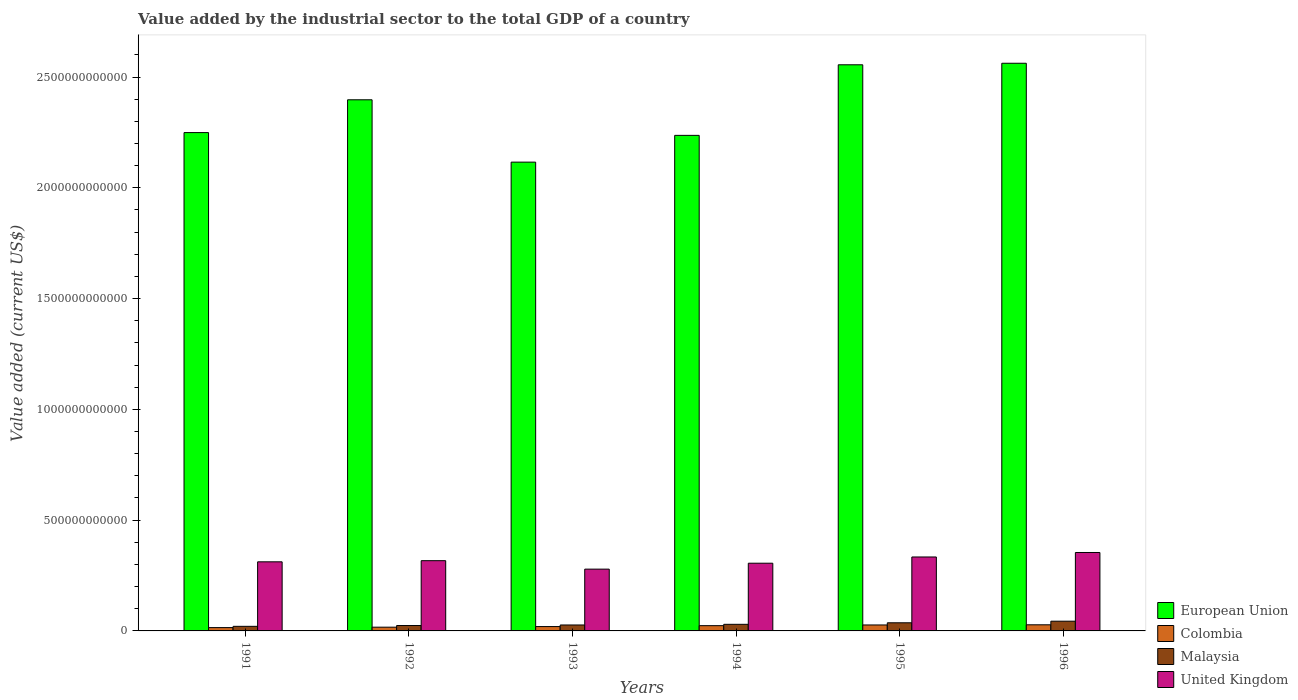How many different coloured bars are there?
Offer a terse response. 4. Are the number of bars per tick equal to the number of legend labels?
Your answer should be compact. Yes. Are the number of bars on each tick of the X-axis equal?
Your response must be concise. Yes. How many bars are there on the 5th tick from the left?
Make the answer very short. 4. How many bars are there on the 3rd tick from the right?
Offer a terse response. 4. What is the label of the 5th group of bars from the left?
Offer a terse response. 1995. In how many cases, is the number of bars for a given year not equal to the number of legend labels?
Keep it short and to the point. 0. What is the value added by the industrial sector to the total GDP in Colombia in 1993?
Make the answer very short. 1.96e+1. Across all years, what is the maximum value added by the industrial sector to the total GDP in Colombia?
Make the answer very short. 2.76e+1. Across all years, what is the minimum value added by the industrial sector to the total GDP in Colombia?
Make the answer very short. 1.50e+1. In which year was the value added by the industrial sector to the total GDP in Malaysia minimum?
Give a very brief answer. 1991. What is the total value added by the industrial sector to the total GDP in Malaysia in the graph?
Make the answer very short. 1.82e+11. What is the difference between the value added by the industrial sector to the total GDP in Malaysia in 1993 and that in 1995?
Your answer should be compact. -9.91e+09. What is the difference between the value added by the industrial sector to the total GDP in Malaysia in 1993 and the value added by the industrial sector to the total GDP in United Kingdom in 1991?
Offer a very short reply. -2.85e+11. What is the average value added by the industrial sector to the total GDP in European Union per year?
Ensure brevity in your answer.  2.35e+12. In the year 1991, what is the difference between the value added by the industrial sector to the total GDP in Colombia and value added by the industrial sector to the total GDP in United Kingdom?
Provide a succinct answer. -2.97e+11. In how many years, is the value added by the industrial sector to the total GDP in European Union greater than 1600000000000 US$?
Make the answer very short. 6. What is the ratio of the value added by the industrial sector to the total GDP in United Kingdom in 1993 to that in 1996?
Your answer should be very brief. 0.79. Is the value added by the industrial sector to the total GDP in European Union in 1994 less than that in 1995?
Your response must be concise. Yes. What is the difference between the highest and the second highest value added by the industrial sector to the total GDP in Malaysia?
Your answer should be very brief. 7.17e+09. What is the difference between the highest and the lowest value added by the industrial sector to the total GDP in European Union?
Make the answer very short. 4.46e+11. What does the 4th bar from the right in 1992 represents?
Provide a succinct answer. European Union. What is the difference between two consecutive major ticks on the Y-axis?
Your answer should be very brief. 5.00e+11. Does the graph contain grids?
Ensure brevity in your answer.  No. Where does the legend appear in the graph?
Provide a short and direct response. Bottom right. What is the title of the graph?
Provide a succinct answer. Value added by the industrial sector to the total GDP of a country. Does "Dominica" appear as one of the legend labels in the graph?
Keep it short and to the point. No. What is the label or title of the Y-axis?
Ensure brevity in your answer.  Value added (current US$). What is the Value added (current US$) of European Union in 1991?
Make the answer very short. 2.25e+12. What is the Value added (current US$) in Colombia in 1991?
Make the answer very short. 1.50e+1. What is the Value added (current US$) in Malaysia in 1991?
Your answer should be very brief. 2.07e+1. What is the Value added (current US$) of United Kingdom in 1991?
Your response must be concise. 3.12e+11. What is the Value added (current US$) of European Union in 1992?
Keep it short and to the point. 2.40e+12. What is the Value added (current US$) of Colombia in 1992?
Keep it short and to the point. 1.69e+1. What is the Value added (current US$) of Malaysia in 1992?
Provide a short and direct response. 2.43e+1. What is the Value added (current US$) in United Kingdom in 1992?
Your answer should be compact. 3.17e+11. What is the Value added (current US$) of European Union in 1993?
Make the answer very short. 2.12e+12. What is the Value added (current US$) in Colombia in 1993?
Keep it short and to the point. 1.96e+1. What is the Value added (current US$) in Malaysia in 1993?
Provide a succinct answer. 2.68e+1. What is the Value added (current US$) of United Kingdom in 1993?
Provide a succinct answer. 2.79e+11. What is the Value added (current US$) in European Union in 1994?
Provide a short and direct response. 2.24e+12. What is the Value added (current US$) of Colombia in 1994?
Give a very brief answer. 2.37e+1. What is the Value added (current US$) in Malaysia in 1994?
Make the answer very short. 2.98e+1. What is the Value added (current US$) of United Kingdom in 1994?
Provide a succinct answer. 3.06e+11. What is the Value added (current US$) in European Union in 1995?
Provide a succinct answer. 2.56e+12. What is the Value added (current US$) of Colombia in 1995?
Your response must be concise. 2.69e+1. What is the Value added (current US$) in Malaysia in 1995?
Keep it short and to the point. 3.67e+1. What is the Value added (current US$) in United Kingdom in 1995?
Make the answer very short. 3.34e+11. What is the Value added (current US$) of European Union in 1996?
Offer a very short reply. 2.56e+12. What is the Value added (current US$) in Colombia in 1996?
Make the answer very short. 2.76e+1. What is the Value added (current US$) of Malaysia in 1996?
Give a very brief answer. 4.39e+1. What is the Value added (current US$) of United Kingdom in 1996?
Make the answer very short. 3.54e+11. Across all years, what is the maximum Value added (current US$) in European Union?
Offer a terse response. 2.56e+12. Across all years, what is the maximum Value added (current US$) of Colombia?
Give a very brief answer. 2.76e+1. Across all years, what is the maximum Value added (current US$) of Malaysia?
Your answer should be very brief. 4.39e+1. Across all years, what is the maximum Value added (current US$) in United Kingdom?
Ensure brevity in your answer.  3.54e+11. Across all years, what is the minimum Value added (current US$) of European Union?
Offer a very short reply. 2.12e+12. Across all years, what is the minimum Value added (current US$) in Colombia?
Keep it short and to the point. 1.50e+1. Across all years, what is the minimum Value added (current US$) in Malaysia?
Provide a succinct answer. 2.07e+1. Across all years, what is the minimum Value added (current US$) in United Kingdom?
Ensure brevity in your answer.  2.79e+11. What is the total Value added (current US$) of European Union in the graph?
Your response must be concise. 1.41e+13. What is the total Value added (current US$) of Colombia in the graph?
Provide a succinct answer. 1.30e+11. What is the total Value added (current US$) of Malaysia in the graph?
Offer a terse response. 1.82e+11. What is the total Value added (current US$) in United Kingdom in the graph?
Your answer should be very brief. 1.90e+12. What is the difference between the Value added (current US$) in European Union in 1991 and that in 1992?
Your response must be concise. -1.48e+11. What is the difference between the Value added (current US$) in Colombia in 1991 and that in 1992?
Ensure brevity in your answer.  -1.91e+09. What is the difference between the Value added (current US$) of Malaysia in 1991 and that in 1992?
Offer a very short reply. -3.65e+09. What is the difference between the Value added (current US$) in United Kingdom in 1991 and that in 1992?
Ensure brevity in your answer.  -5.13e+09. What is the difference between the Value added (current US$) of European Union in 1991 and that in 1993?
Ensure brevity in your answer.  1.33e+11. What is the difference between the Value added (current US$) of Colombia in 1991 and that in 1993?
Provide a succinct answer. -4.66e+09. What is the difference between the Value added (current US$) of Malaysia in 1991 and that in 1993?
Your response must be concise. -6.12e+09. What is the difference between the Value added (current US$) of United Kingdom in 1991 and that in 1993?
Give a very brief answer. 3.30e+1. What is the difference between the Value added (current US$) of European Union in 1991 and that in 1994?
Give a very brief answer. 1.25e+1. What is the difference between the Value added (current US$) of Colombia in 1991 and that in 1994?
Your response must be concise. -8.73e+09. What is the difference between the Value added (current US$) in Malaysia in 1991 and that in 1994?
Provide a short and direct response. -9.13e+09. What is the difference between the Value added (current US$) in United Kingdom in 1991 and that in 1994?
Your response must be concise. 6.26e+09. What is the difference between the Value added (current US$) of European Union in 1991 and that in 1995?
Keep it short and to the point. -3.06e+11. What is the difference between the Value added (current US$) in Colombia in 1991 and that in 1995?
Provide a short and direct response. -1.19e+1. What is the difference between the Value added (current US$) in Malaysia in 1991 and that in 1995?
Make the answer very short. -1.60e+1. What is the difference between the Value added (current US$) of United Kingdom in 1991 and that in 1995?
Provide a short and direct response. -2.19e+1. What is the difference between the Value added (current US$) of European Union in 1991 and that in 1996?
Your answer should be very brief. -3.13e+11. What is the difference between the Value added (current US$) in Colombia in 1991 and that in 1996?
Provide a succinct answer. -1.26e+1. What is the difference between the Value added (current US$) in Malaysia in 1991 and that in 1996?
Give a very brief answer. -2.32e+1. What is the difference between the Value added (current US$) of United Kingdom in 1991 and that in 1996?
Your answer should be very brief. -4.21e+1. What is the difference between the Value added (current US$) in European Union in 1992 and that in 1993?
Your answer should be very brief. 2.81e+11. What is the difference between the Value added (current US$) of Colombia in 1992 and that in 1993?
Provide a short and direct response. -2.75e+09. What is the difference between the Value added (current US$) in Malaysia in 1992 and that in 1993?
Your answer should be very brief. -2.47e+09. What is the difference between the Value added (current US$) of United Kingdom in 1992 and that in 1993?
Your answer should be compact. 3.81e+1. What is the difference between the Value added (current US$) of European Union in 1992 and that in 1994?
Ensure brevity in your answer.  1.61e+11. What is the difference between the Value added (current US$) in Colombia in 1992 and that in 1994?
Make the answer very short. -6.82e+09. What is the difference between the Value added (current US$) of Malaysia in 1992 and that in 1994?
Provide a short and direct response. -5.48e+09. What is the difference between the Value added (current US$) of United Kingdom in 1992 and that in 1994?
Your response must be concise. 1.14e+1. What is the difference between the Value added (current US$) in European Union in 1992 and that in 1995?
Make the answer very short. -1.58e+11. What is the difference between the Value added (current US$) of Colombia in 1992 and that in 1995?
Your response must be concise. -1.00e+1. What is the difference between the Value added (current US$) in Malaysia in 1992 and that in 1995?
Your response must be concise. -1.24e+1. What is the difference between the Value added (current US$) in United Kingdom in 1992 and that in 1995?
Offer a terse response. -1.68e+1. What is the difference between the Value added (current US$) of European Union in 1992 and that in 1996?
Your answer should be compact. -1.65e+11. What is the difference between the Value added (current US$) of Colombia in 1992 and that in 1996?
Keep it short and to the point. -1.07e+1. What is the difference between the Value added (current US$) in Malaysia in 1992 and that in 1996?
Provide a short and direct response. -1.96e+1. What is the difference between the Value added (current US$) in United Kingdom in 1992 and that in 1996?
Your response must be concise. -3.70e+1. What is the difference between the Value added (current US$) in European Union in 1993 and that in 1994?
Make the answer very short. -1.21e+11. What is the difference between the Value added (current US$) in Colombia in 1993 and that in 1994?
Provide a succinct answer. -4.07e+09. What is the difference between the Value added (current US$) in Malaysia in 1993 and that in 1994?
Offer a very short reply. -3.01e+09. What is the difference between the Value added (current US$) of United Kingdom in 1993 and that in 1994?
Offer a terse response. -2.67e+1. What is the difference between the Value added (current US$) in European Union in 1993 and that in 1995?
Give a very brief answer. -4.39e+11. What is the difference between the Value added (current US$) of Colombia in 1993 and that in 1995?
Your answer should be very brief. -7.26e+09. What is the difference between the Value added (current US$) in Malaysia in 1993 and that in 1995?
Give a very brief answer. -9.91e+09. What is the difference between the Value added (current US$) of United Kingdom in 1993 and that in 1995?
Offer a very short reply. -5.49e+1. What is the difference between the Value added (current US$) in European Union in 1993 and that in 1996?
Your response must be concise. -4.46e+11. What is the difference between the Value added (current US$) in Colombia in 1993 and that in 1996?
Provide a succinct answer. -7.99e+09. What is the difference between the Value added (current US$) in Malaysia in 1993 and that in 1996?
Your response must be concise. -1.71e+1. What is the difference between the Value added (current US$) in United Kingdom in 1993 and that in 1996?
Keep it short and to the point. -7.51e+1. What is the difference between the Value added (current US$) of European Union in 1994 and that in 1995?
Provide a short and direct response. -3.19e+11. What is the difference between the Value added (current US$) in Colombia in 1994 and that in 1995?
Ensure brevity in your answer.  -3.20e+09. What is the difference between the Value added (current US$) in Malaysia in 1994 and that in 1995?
Provide a short and direct response. -6.90e+09. What is the difference between the Value added (current US$) of United Kingdom in 1994 and that in 1995?
Provide a short and direct response. -2.81e+1. What is the difference between the Value added (current US$) of European Union in 1994 and that in 1996?
Give a very brief answer. -3.25e+11. What is the difference between the Value added (current US$) of Colombia in 1994 and that in 1996?
Provide a succinct answer. -3.92e+09. What is the difference between the Value added (current US$) in Malaysia in 1994 and that in 1996?
Your response must be concise. -1.41e+1. What is the difference between the Value added (current US$) of United Kingdom in 1994 and that in 1996?
Provide a succinct answer. -4.83e+1. What is the difference between the Value added (current US$) of European Union in 1995 and that in 1996?
Provide a succinct answer. -6.93e+09. What is the difference between the Value added (current US$) of Colombia in 1995 and that in 1996?
Provide a short and direct response. -7.25e+08. What is the difference between the Value added (current US$) of Malaysia in 1995 and that in 1996?
Provide a succinct answer. -7.17e+09. What is the difference between the Value added (current US$) in United Kingdom in 1995 and that in 1996?
Provide a short and direct response. -2.02e+1. What is the difference between the Value added (current US$) of European Union in 1991 and the Value added (current US$) of Colombia in 1992?
Offer a terse response. 2.23e+12. What is the difference between the Value added (current US$) of European Union in 1991 and the Value added (current US$) of Malaysia in 1992?
Give a very brief answer. 2.22e+12. What is the difference between the Value added (current US$) in European Union in 1991 and the Value added (current US$) in United Kingdom in 1992?
Make the answer very short. 1.93e+12. What is the difference between the Value added (current US$) of Colombia in 1991 and the Value added (current US$) of Malaysia in 1992?
Keep it short and to the point. -9.38e+09. What is the difference between the Value added (current US$) in Colombia in 1991 and the Value added (current US$) in United Kingdom in 1992?
Give a very brief answer. -3.02e+11. What is the difference between the Value added (current US$) of Malaysia in 1991 and the Value added (current US$) of United Kingdom in 1992?
Provide a short and direct response. -2.96e+11. What is the difference between the Value added (current US$) of European Union in 1991 and the Value added (current US$) of Colombia in 1993?
Offer a terse response. 2.23e+12. What is the difference between the Value added (current US$) in European Union in 1991 and the Value added (current US$) in Malaysia in 1993?
Ensure brevity in your answer.  2.22e+12. What is the difference between the Value added (current US$) in European Union in 1991 and the Value added (current US$) in United Kingdom in 1993?
Offer a terse response. 1.97e+12. What is the difference between the Value added (current US$) of Colombia in 1991 and the Value added (current US$) of Malaysia in 1993?
Your response must be concise. -1.18e+1. What is the difference between the Value added (current US$) of Colombia in 1991 and the Value added (current US$) of United Kingdom in 1993?
Your answer should be very brief. -2.64e+11. What is the difference between the Value added (current US$) in Malaysia in 1991 and the Value added (current US$) in United Kingdom in 1993?
Offer a terse response. -2.58e+11. What is the difference between the Value added (current US$) in European Union in 1991 and the Value added (current US$) in Colombia in 1994?
Ensure brevity in your answer.  2.23e+12. What is the difference between the Value added (current US$) in European Union in 1991 and the Value added (current US$) in Malaysia in 1994?
Your response must be concise. 2.22e+12. What is the difference between the Value added (current US$) in European Union in 1991 and the Value added (current US$) in United Kingdom in 1994?
Give a very brief answer. 1.94e+12. What is the difference between the Value added (current US$) of Colombia in 1991 and the Value added (current US$) of Malaysia in 1994?
Provide a short and direct response. -1.49e+1. What is the difference between the Value added (current US$) in Colombia in 1991 and the Value added (current US$) in United Kingdom in 1994?
Provide a short and direct response. -2.91e+11. What is the difference between the Value added (current US$) of Malaysia in 1991 and the Value added (current US$) of United Kingdom in 1994?
Make the answer very short. -2.85e+11. What is the difference between the Value added (current US$) in European Union in 1991 and the Value added (current US$) in Colombia in 1995?
Offer a terse response. 2.22e+12. What is the difference between the Value added (current US$) in European Union in 1991 and the Value added (current US$) in Malaysia in 1995?
Provide a succinct answer. 2.21e+12. What is the difference between the Value added (current US$) in European Union in 1991 and the Value added (current US$) in United Kingdom in 1995?
Make the answer very short. 1.92e+12. What is the difference between the Value added (current US$) in Colombia in 1991 and the Value added (current US$) in Malaysia in 1995?
Give a very brief answer. -2.18e+1. What is the difference between the Value added (current US$) in Colombia in 1991 and the Value added (current US$) in United Kingdom in 1995?
Give a very brief answer. -3.19e+11. What is the difference between the Value added (current US$) of Malaysia in 1991 and the Value added (current US$) of United Kingdom in 1995?
Provide a succinct answer. -3.13e+11. What is the difference between the Value added (current US$) of European Union in 1991 and the Value added (current US$) of Colombia in 1996?
Your answer should be compact. 2.22e+12. What is the difference between the Value added (current US$) in European Union in 1991 and the Value added (current US$) in Malaysia in 1996?
Provide a short and direct response. 2.21e+12. What is the difference between the Value added (current US$) in European Union in 1991 and the Value added (current US$) in United Kingdom in 1996?
Ensure brevity in your answer.  1.90e+12. What is the difference between the Value added (current US$) in Colombia in 1991 and the Value added (current US$) in Malaysia in 1996?
Keep it short and to the point. -2.89e+1. What is the difference between the Value added (current US$) of Colombia in 1991 and the Value added (current US$) of United Kingdom in 1996?
Make the answer very short. -3.39e+11. What is the difference between the Value added (current US$) in Malaysia in 1991 and the Value added (current US$) in United Kingdom in 1996?
Offer a very short reply. -3.33e+11. What is the difference between the Value added (current US$) in European Union in 1992 and the Value added (current US$) in Colombia in 1993?
Make the answer very short. 2.38e+12. What is the difference between the Value added (current US$) of European Union in 1992 and the Value added (current US$) of Malaysia in 1993?
Give a very brief answer. 2.37e+12. What is the difference between the Value added (current US$) of European Union in 1992 and the Value added (current US$) of United Kingdom in 1993?
Offer a terse response. 2.12e+12. What is the difference between the Value added (current US$) in Colombia in 1992 and the Value added (current US$) in Malaysia in 1993?
Provide a short and direct response. -9.94e+09. What is the difference between the Value added (current US$) of Colombia in 1992 and the Value added (current US$) of United Kingdom in 1993?
Your answer should be compact. -2.62e+11. What is the difference between the Value added (current US$) of Malaysia in 1992 and the Value added (current US$) of United Kingdom in 1993?
Provide a short and direct response. -2.55e+11. What is the difference between the Value added (current US$) of European Union in 1992 and the Value added (current US$) of Colombia in 1994?
Make the answer very short. 2.37e+12. What is the difference between the Value added (current US$) of European Union in 1992 and the Value added (current US$) of Malaysia in 1994?
Offer a very short reply. 2.37e+12. What is the difference between the Value added (current US$) in European Union in 1992 and the Value added (current US$) in United Kingdom in 1994?
Provide a short and direct response. 2.09e+12. What is the difference between the Value added (current US$) of Colombia in 1992 and the Value added (current US$) of Malaysia in 1994?
Give a very brief answer. -1.29e+1. What is the difference between the Value added (current US$) of Colombia in 1992 and the Value added (current US$) of United Kingdom in 1994?
Keep it short and to the point. -2.89e+11. What is the difference between the Value added (current US$) of Malaysia in 1992 and the Value added (current US$) of United Kingdom in 1994?
Ensure brevity in your answer.  -2.81e+11. What is the difference between the Value added (current US$) of European Union in 1992 and the Value added (current US$) of Colombia in 1995?
Your response must be concise. 2.37e+12. What is the difference between the Value added (current US$) of European Union in 1992 and the Value added (current US$) of Malaysia in 1995?
Ensure brevity in your answer.  2.36e+12. What is the difference between the Value added (current US$) of European Union in 1992 and the Value added (current US$) of United Kingdom in 1995?
Your answer should be compact. 2.06e+12. What is the difference between the Value added (current US$) of Colombia in 1992 and the Value added (current US$) of Malaysia in 1995?
Your response must be concise. -1.98e+1. What is the difference between the Value added (current US$) of Colombia in 1992 and the Value added (current US$) of United Kingdom in 1995?
Your response must be concise. -3.17e+11. What is the difference between the Value added (current US$) of Malaysia in 1992 and the Value added (current US$) of United Kingdom in 1995?
Your answer should be very brief. -3.09e+11. What is the difference between the Value added (current US$) of European Union in 1992 and the Value added (current US$) of Colombia in 1996?
Provide a short and direct response. 2.37e+12. What is the difference between the Value added (current US$) of European Union in 1992 and the Value added (current US$) of Malaysia in 1996?
Your answer should be compact. 2.35e+12. What is the difference between the Value added (current US$) of European Union in 1992 and the Value added (current US$) of United Kingdom in 1996?
Ensure brevity in your answer.  2.04e+12. What is the difference between the Value added (current US$) of Colombia in 1992 and the Value added (current US$) of Malaysia in 1996?
Give a very brief answer. -2.70e+1. What is the difference between the Value added (current US$) of Colombia in 1992 and the Value added (current US$) of United Kingdom in 1996?
Your response must be concise. -3.37e+11. What is the difference between the Value added (current US$) in Malaysia in 1992 and the Value added (current US$) in United Kingdom in 1996?
Provide a succinct answer. -3.30e+11. What is the difference between the Value added (current US$) in European Union in 1993 and the Value added (current US$) in Colombia in 1994?
Provide a succinct answer. 2.09e+12. What is the difference between the Value added (current US$) in European Union in 1993 and the Value added (current US$) in Malaysia in 1994?
Your answer should be compact. 2.09e+12. What is the difference between the Value added (current US$) in European Union in 1993 and the Value added (current US$) in United Kingdom in 1994?
Your answer should be very brief. 1.81e+12. What is the difference between the Value added (current US$) in Colombia in 1993 and the Value added (current US$) in Malaysia in 1994?
Your response must be concise. -1.02e+1. What is the difference between the Value added (current US$) of Colombia in 1993 and the Value added (current US$) of United Kingdom in 1994?
Provide a short and direct response. -2.86e+11. What is the difference between the Value added (current US$) of Malaysia in 1993 and the Value added (current US$) of United Kingdom in 1994?
Give a very brief answer. -2.79e+11. What is the difference between the Value added (current US$) of European Union in 1993 and the Value added (current US$) of Colombia in 1995?
Offer a terse response. 2.09e+12. What is the difference between the Value added (current US$) of European Union in 1993 and the Value added (current US$) of Malaysia in 1995?
Your response must be concise. 2.08e+12. What is the difference between the Value added (current US$) of European Union in 1993 and the Value added (current US$) of United Kingdom in 1995?
Keep it short and to the point. 1.78e+12. What is the difference between the Value added (current US$) of Colombia in 1993 and the Value added (current US$) of Malaysia in 1995?
Your answer should be compact. -1.71e+1. What is the difference between the Value added (current US$) of Colombia in 1993 and the Value added (current US$) of United Kingdom in 1995?
Give a very brief answer. -3.14e+11. What is the difference between the Value added (current US$) of Malaysia in 1993 and the Value added (current US$) of United Kingdom in 1995?
Make the answer very short. -3.07e+11. What is the difference between the Value added (current US$) in European Union in 1993 and the Value added (current US$) in Colombia in 1996?
Make the answer very short. 2.09e+12. What is the difference between the Value added (current US$) of European Union in 1993 and the Value added (current US$) of Malaysia in 1996?
Make the answer very short. 2.07e+12. What is the difference between the Value added (current US$) in European Union in 1993 and the Value added (current US$) in United Kingdom in 1996?
Offer a terse response. 1.76e+12. What is the difference between the Value added (current US$) of Colombia in 1993 and the Value added (current US$) of Malaysia in 1996?
Provide a succinct answer. -2.43e+1. What is the difference between the Value added (current US$) in Colombia in 1993 and the Value added (current US$) in United Kingdom in 1996?
Provide a succinct answer. -3.34e+11. What is the difference between the Value added (current US$) of Malaysia in 1993 and the Value added (current US$) of United Kingdom in 1996?
Your answer should be compact. -3.27e+11. What is the difference between the Value added (current US$) in European Union in 1994 and the Value added (current US$) in Colombia in 1995?
Your answer should be very brief. 2.21e+12. What is the difference between the Value added (current US$) in European Union in 1994 and the Value added (current US$) in Malaysia in 1995?
Offer a terse response. 2.20e+12. What is the difference between the Value added (current US$) of European Union in 1994 and the Value added (current US$) of United Kingdom in 1995?
Make the answer very short. 1.90e+12. What is the difference between the Value added (current US$) in Colombia in 1994 and the Value added (current US$) in Malaysia in 1995?
Offer a very short reply. -1.30e+1. What is the difference between the Value added (current US$) of Colombia in 1994 and the Value added (current US$) of United Kingdom in 1995?
Offer a terse response. -3.10e+11. What is the difference between the Value added (current US$) of Malaysia in 1994 and the Value added (current US$) of United Kingdom in 1995?
Your response must be concise. -3.04e+11. What is the difference between the Value added (current US$) in European Union in 1994 and the Value added (current US$) in Colombia in 1996?
Your answer should be compact. 2.21e+12. What is the difference between the Value added (current US$) of European Union in 1994 and the Value added (current US$) of Malaysia in 1996?
Ensure brevity in your answer.  2.19e+12. What is the difference between the Value added (current US$) in European Union in 1994 and the Value added (current US$) in United Kingdom in 1996?
Give a very brief answer. 1.88e+12. What is the difference between the Value added (current US$) of Colombia in 1994 and the Value added (current US$) of Malaysia in 1996?
Make the answer very short. -2.02e+1. What is the difference between the Value added (current US$) of Colombia in 1994 and the Value added (current US$) of United Kingdom in 1996?
Give a very brief answer. -3.30e+11. What is the difference between the Value added (current US$) in Malaysia in 1994 and the Value added (current US$) in United Kingdom in 1996?
Provide a succinct answer. -3.24e+11. What is the difference between the Value added (current US$) of European Union in 1995 and the Value added (current US$) of Colombia in 1996?
Your answer should be compact. 2.53e+12. What is the difference between the Value added (current US$) in European Union in 1995 and the Value added (current US$) in Malaysia in 1996?
Give a very brief answer. 2.51e+12. What is the difference between the Value added (current US$) in European Union in 1995 and the Value added (current US$) in United Kingdom in 1996?
Your response must be concise. 2.20e+12. What is the difference between the Value added (current US$) of Colombia in 1995 and the Value added (current US$) of Malaysia in 1996?
Ensure brevity in your answer.  -1.70e+1. What is the difference between the Value added (current US$) in Colombia in 1995 and the Value added (current US$) in United Kingdom in 1996?
Provide a short and direct response. -3.27e+11. What is the difference between the Value added (current US$) of Malaysia in 1995 and the Value added (current US$) of United Kingdom in 1996?
Keep it short and to the point. -3.17e+11. What is the average Value added (current US$) in European Union per year?
Make the answer very short. 2.35e+12. What is the average Value added (current US$) in Colombia per year?
Your answer should be very brief. 2.16e+1. What is the average Value added (current US$) in Malaysia per year?
Make the answer very short. 3.04e+1. What is the average Value added (current US$) in United Kingdom per year?
Ensure brevity in your answer.  3.17e+11. In the year 1991, what is the difference between the Value added (current US$) in European Union and Value added (current US$) in Colombia?
Your response must be concise. 2.23e+12. In the year 1991, what is the difference between the Value added (current US$) in European Union and Value added (current US$) in Malaysia?
Your answer should be very brief. 2.23e+12. In the year 1991, what is the difference between the Value added (current US$) of European Union and Value added (current US$) of United Kingdom?
Provide a succinct answer. 1.94e+12. In the year 1991, what is the difference between the Value added (current US$) in Colombia and Value added (current US$) in Malaysia?
Ensure brevity in your answer.  -5.72e+09. In the year 1991, what is the difference between the Value added (current US$) of Colombia and Value added (current US$) of United Kingdom?
Provide a succinct answer. -2.97e+11. In the year 1991, what is the difference between the Value added (current US$) of Malaysia and Value added (current US$) of United Kingdom?
Your answer should be compact. -2.91e+11. In the year 1992, what is the difference between the Value added (current US$) in European Union and Value added (current US$) in Colombia?
Offer a very short reply. 2.38e+12. In the year 1992, what is the difference between the Value added (current US$) of European Union and Value added (current US$) of Malaysia?
Keep it short and to the point. 2.37e+12. In the year 1992, what is the difference between the Value added (current US$) in European Union and Value added (current US$) in United Kingdom?
Keep it short and to the point. 2.08e+12. In the year 1992, what is the difference between the Value added (current US$) in Colombia and Value added (current US$) in Malaysia?
Offer a terse response. -7.47e+09. In the year 1992, what is the difference between the Value added (current US$) in Colombia and Value added (current US$) in United Kingdom?
Offer a very short reply. -3.00e+11. In the year 1992, what is the difference between the Value added (current US$) of Malaysia and Value added (current US$) of United Kingdom?
Your answer should be very brief. -2.93e+11. In the year 1993, what is the difference between the Value added (current US$) of European Union and Value added (current US$) of Colombia?
Your answer should be very brief. 2.10e+12. In the year 1993, what is the difference between the Value added (current US$) in European Union and Value added (current US$) in Malaysia?
Give a very brief answer. 2.09e+12. In the year 1993, what is the difference between the Value added (current US$) in European Union and Value added (current US$) in United Kingdom?
Your answer should be compact. 1.84e+12. In the year 1993, what is the difference between the Value added (current US$) of Colombia and Value added (current US$) of Malaysia?
Your response must be concise. -7.19e+09. In the year 1993, what is the difference between the Value added (current US$) of Colombia and Value added (current US$) of United Kingdom?
Offer a very short reply. -2.59e+11. In the year 1993, what is the difference between the Value added (current US$) of Malaysia and Value added (current US$) of United Kingdom?
Your answer should be compact. -2.52e+11. In the year 1994, what is the difference between the Value added (current US$) in European Union and Value added (current US$) in Colombia?
Give a very brief answer. 2.21e+12. In the year 1994, what is the difference between the Value added (current US$) in European Union and Value added (current US$) in Malaysia?
Make the answer very short. 2.21e+12. In the year 1994, what is the difference between the Value added (current US$) in European Union and Value added (current US$) in United Kingdom?
Offer a very short reply. 1.93e+12. In the year 1994, what is the difference between the Value added (current US$) of Colombia and Value added (current US$) of Malaysia?
Offer a terse response. -6.13e+09. In the year 1994, what is the difference between the Value added (current US$) of Colombia and Value added (current US$) of United Kingdom?
Offer a terse response. -2.82e+11. In the year 1994, what is the difference between the Value added (current US$) of Malaysia and Value added (current US$) of United Kingdom?
Your answer should be compact. -2.76e+11. In the year 1995, what is the difference between the Value added (current US$) of European Union and Value added (current US$) of Colombia?
Your answer should be compact. 2.53e+12. In the year 1995, what is the difference between the Value added (current US$) of European Union and Value added (current US$) of Malaysia?
Offer a very short reply. 2.52e+12. In the year 1995, what is the difference between the Value added (current US$) in European Union and Value added (current US$) in United Kingdom?
Provide a succinct answer. 2.22e+12. In the year 1995, what is the difference between the Value added (current US$) of Colombia and Value added (current US$) of Malaysia?
Offer a very short reply. -9.84e+09. In the year 1995, what is the difference between the Value added (current US$) in Colombia and Value added (current US$) in United Kingdom?
Offer a very short reply. -3.07e+11. In the year 1995, what is the difference between the Value added (current US$) of Malaysia and Value added (current US$) of United Kingdom?
Offer a very short reply. -2.97e+11. In the year 1996, what is the difference between the Value added (current US$) of European Union and Value added (current US$) of Colombia?
Your answer should be compact. 2.53e+12. In the year 1996, what is the difference between the Value added (current US$) of European Union and Value added (current US$) of Malaysia?
Ensure brevity in your answer.  2.52e+12. In the year 1996, what is the difference between the Value added (current US$) in European Union and Value added (current US$) in United Kingdom?
Provide a short and direct response. 2.21e+12. In the year 1996, what is the difference between the Value added (current US$) in Colombia and Value added (current US$) in Malaysia?
Ensure brevity in your answer.  -1.63e+1. In the year 1996, what is the difference between the Value added (current US$) in Colombia and Value added (current US$) in United Kingdom?
Your answer should be compact. -3.26e+11. In the year 1996, what is the difference between the Value added (current US$) of Malaysia and Value added (current US$) of United Kingdom?
Provide a succinct answer. -3.10e+11. What is the ratio of the Value added (current US$) of European Union in 1991 to that in 1992?
Provide a succinct answer. 0.94. What is the ratio of the Value added (current US$) of Colombia in 1991 to that in 1992?
Ensure brevity in your answer.  0.89. What is the ratio of the Value added (current US$) in Malaysia in 1991 to that in 1992?
Ensure brevity in your answer.  0.85. What is the ratio of the Value added (current US$) in United Kingdom in 1991 to that in 1992?
Provide a short and direct response. 0.98. What is the ratio of the Value added (current US$) of European Union in 1991 to that in 1993?
Keep it short and to the point. 1.06. What is the ratio of the Value added (current US$) of Colombia in 1991 to that in 1993?
Offer a very short reply. 0.76. What is the ratio of the Value added (current US$) of Malaysia in 1991 to that in 1993?
Provide a succinct answer. 0.77. What is the ratio of the Value added (current US$) in United Kingdom in 1991 to that in 1993?
Your answer should be compact. 1.12. What is the ratio of the Value added (current US$) of European Union in 1991 to that in 1994?
Provide a short and direct response. 1.01. What is the ratio of the Value added (current US$) in Colombia in 1991 to that in 1994?
Your response must be concise. 0.63. What is the ratio of the Value added (current US$) of Malaysia in 1991 to that in 1994?
Provide a short and direct response. 0.69. What is the ratio of the Value added (current US$) of United Kingdom in 1991 to that in 1994?
Ensure brevity in your answer.  1.02. What is the ratio of the Value added (current US$) of European Union in 1991 to that in 1995?
Ensure brevity in your answer.  0.88. What is the ratio of the Value added (current US$) in Colombia in 1991 to that in 1995?
Offer a very short reply. 0.56. What is the ratio of the Value added (current US$) in Malaysia in 1991 to that in 1995?
Give a very brief answer. 0.56. What is the ratio of the Value added (current US$) of United Kingdom in 1991 to that in 1995?
Offer a very short reply. 0.93. What is the ratio of the Value added (current US$) in European Union in 1991 to that in 1996?
Give a very brief answer. 0.88. What is the ratio of the Value added (current US$) of Colombia in 1991 to that in 1996?
Offer a terse response. 0.54. What is the ratio of the Value added (current US$) in Malaysia in 1991 to that in 1996?
Keep it short and to the point. 0.47. What is the ratio of the Value added (current US$) in United Kingdom in 1991 to that in 1996?
Your answer should be compact. 0.88. What is the ratio of the Value added (current US$) in European Union in 1992 to that in 1993?
Offer a terse response. 1.13. What is the ratio of the Value added (current US$) of Colombia in 1992 to that in 1993?
Provide a succinct answer. 0.86. What is the ratio of the Value added (current US$) of Malaysia in 1992 to that in 1993?
Offer a very short reply. 0.91. What is the ratio of the Value added (current US$) in United Kingdom in 1992 to that in 1993?
Offer a terse response. 1.14. What is the ratio of the Value added (current US$) of European Union in 1992 to that in 1994?
Provide a succinct answer. 1.07. What is the ratio of the Value added (current US$) of Colombia in 1992 to that in 1994?
Provide a succinct answer. 0.71. What is the ratio of the Value added (current US$) in Malaysia in 1992 to that in 1994?
Provide a short and direct response. 0.82. What is the ratio of the Value added (current US$) in United Kingdom in 1992 to that in 1994?
Ensure brevity in your answer.  1.04. What is the ratio of the Value added (current US$) in European Union in 1992 to that in 1995?
Ensure brevity in your answer.  0.94. What is the ratio of the Value added (current US$) of Colombia in 1992 to that in 1995?
Provide a succinct answer. 0.63. What is the ratio of the Value added (current US$) of Malaysia in 1992 to that in 1995?
Ensure brevity in your answer.  0.66. What is the ratio of the Value added (current US$) of United Kingdom in 1992 to that in 1995?
Your answer should be very brief. 0.95. What is the ratio of the Value added (current US$) of European Union in 1992 to that in 1996?
Ensure brevity in your answer.  0.94. What is the ratio of the Value added (current US$) in Colombia in 1992 to that in 1996?
Give a very brief answer. 0.61. What is the ratio of the Value added (current US$) in Malaysia in 1992 to that in 1996?
Offer a very short reply. 0.55. What is the ratio of the Value added (current US$) in United Kingdom in 1992 to that in 1996?
Make the answer very short. 0.9. What is the ratio of the Value added (current US$) of European Union in 1993 to that in 1994?
Offer a terse response. 0.95. What is the ratio of the Value added (current US$) of Colombia in 1993 to that in 1994?
Offer a very short reply. 0.83. What is the ratio of the Value added (current US$) in Malaysia in 1993 to that in 1994?
Your response must be concise. 0.9. What is the ratio of the Value added (current US$) in United Kingdom in 1993 to that in 1994?
Offer a terse response. 0.91. What is the ratio of the Value added (current US$) in European Union in 1993 to that in 1995?
Offer a terse response. 0.83. What is the ratio of the Value added (current US$) in Colombia in 1993 to that in 1995?
Offer a very short reply. 0.73. What is the ratio of the Value added (current US$) of Malaysia in 1993 to that in 1995?
Offer a very short reply. 0.73. What is the ratio of the Value added (current US$) in United Kingdom in 1993 to that in 1995?
Make the answer very short. 0.84. What is the ratio of the Value added (current US$) in European Union in 1993 to that in 1996?
Make the answer very short. 0.83. What is the ratio of the Value added (current US$) in Colombia in 1993 to that in 1996?
Your response must be concise. 0.71. What is the ratio of the Value added (current US$) in Malaysia in 1993 to that in 1996?
Give a very brief answer. 0.61. What is the ratio of the Value added (current US$) in United Kingdom in 1993 to that in 1996?
Keep it short and to the point. 0.79. What is the ratio of the Value added (current US$) in European Union in 1994 to that in 1995?
Ensure brevity in your answer.  0.88. What is the ratio of the Value added (current US$) in Colombia in 1994 to that in 1995?
Offer a very short reply. 0.88. What is the ratio of the Value added (current US$) of Malaysia in 1994 to that in 1995?
Provide a succinct answer. 0.81. What is the ratio of the Value added (current US$) in United Kingdom in 1994 to that in 1995?
Keep it short and to the point. 0.92. What is the ratio of the Value added (current US$) in European Union in 1994 to that in 1996?
Provide a succinct answer. 0.87. What is the ratio of the Value added (current US$) in Colombia in 1994 to that in 1996?
Provide a short and direct response. 0.86. What is the ratio of the Value added (current US$) of Malaysia in 1994 to that in 1996?
Keep it short and to the point. 0.68. What is the ratio of the Value added (current US$) in United Kingdom in 1994 to that in 1996?
Offer a very short reply. 0.86. What is the ratio of the Value added (current US$) in European Union in 1995 to that in 1996?
Keep it short and to the point. 1. What is the ratio of the Value added (current US$) in Colombia in 1995 to that in 1996?
Your answer should be very brief. 0.97. What is the ratio of the Value added (current US$) in Malaysia in 1995 to that in 1996?
Ensure brevity in your answer.  0.84. What is the ratio of the Value added (current US$) of United Kingdom in 1995 to that in 1996?
Give a very brief answer. 0.94. What is the difference between the highest and the second highest Value added (current US$) in European Union?
Offer a very short reply. 6.93e+09. What is the difference between the highest and the second highest Value added (current US$) of Colombia?
Make the answer very short. 7.25e+08. What is the difference between the highest and the second highest Value added (current US$) in Malaysia?
Offer a very short reply. 7.17e+09. What is the difference between the highest and the second highest Value added (current US$) in United Kingdom?
Your answer should be compact. 2.02e+1. What is the difference between the highest and the lowest Value added (current US$) of European Union?
Make the answer very short. 4.46e+11. What is the difference between the highest and the lowest Value added (current US$) of Colombia?
Offer a very short reply. 1.26e+1. What is the difference between the highest and the lowest Value added (current US$) in Malaysia?
Make the answer very short. 2.32e+1. What is the difference between the highest and the lowest Value added (current US$) in United Kingdom?
Provide a succinct answer. 7.51e+1. 